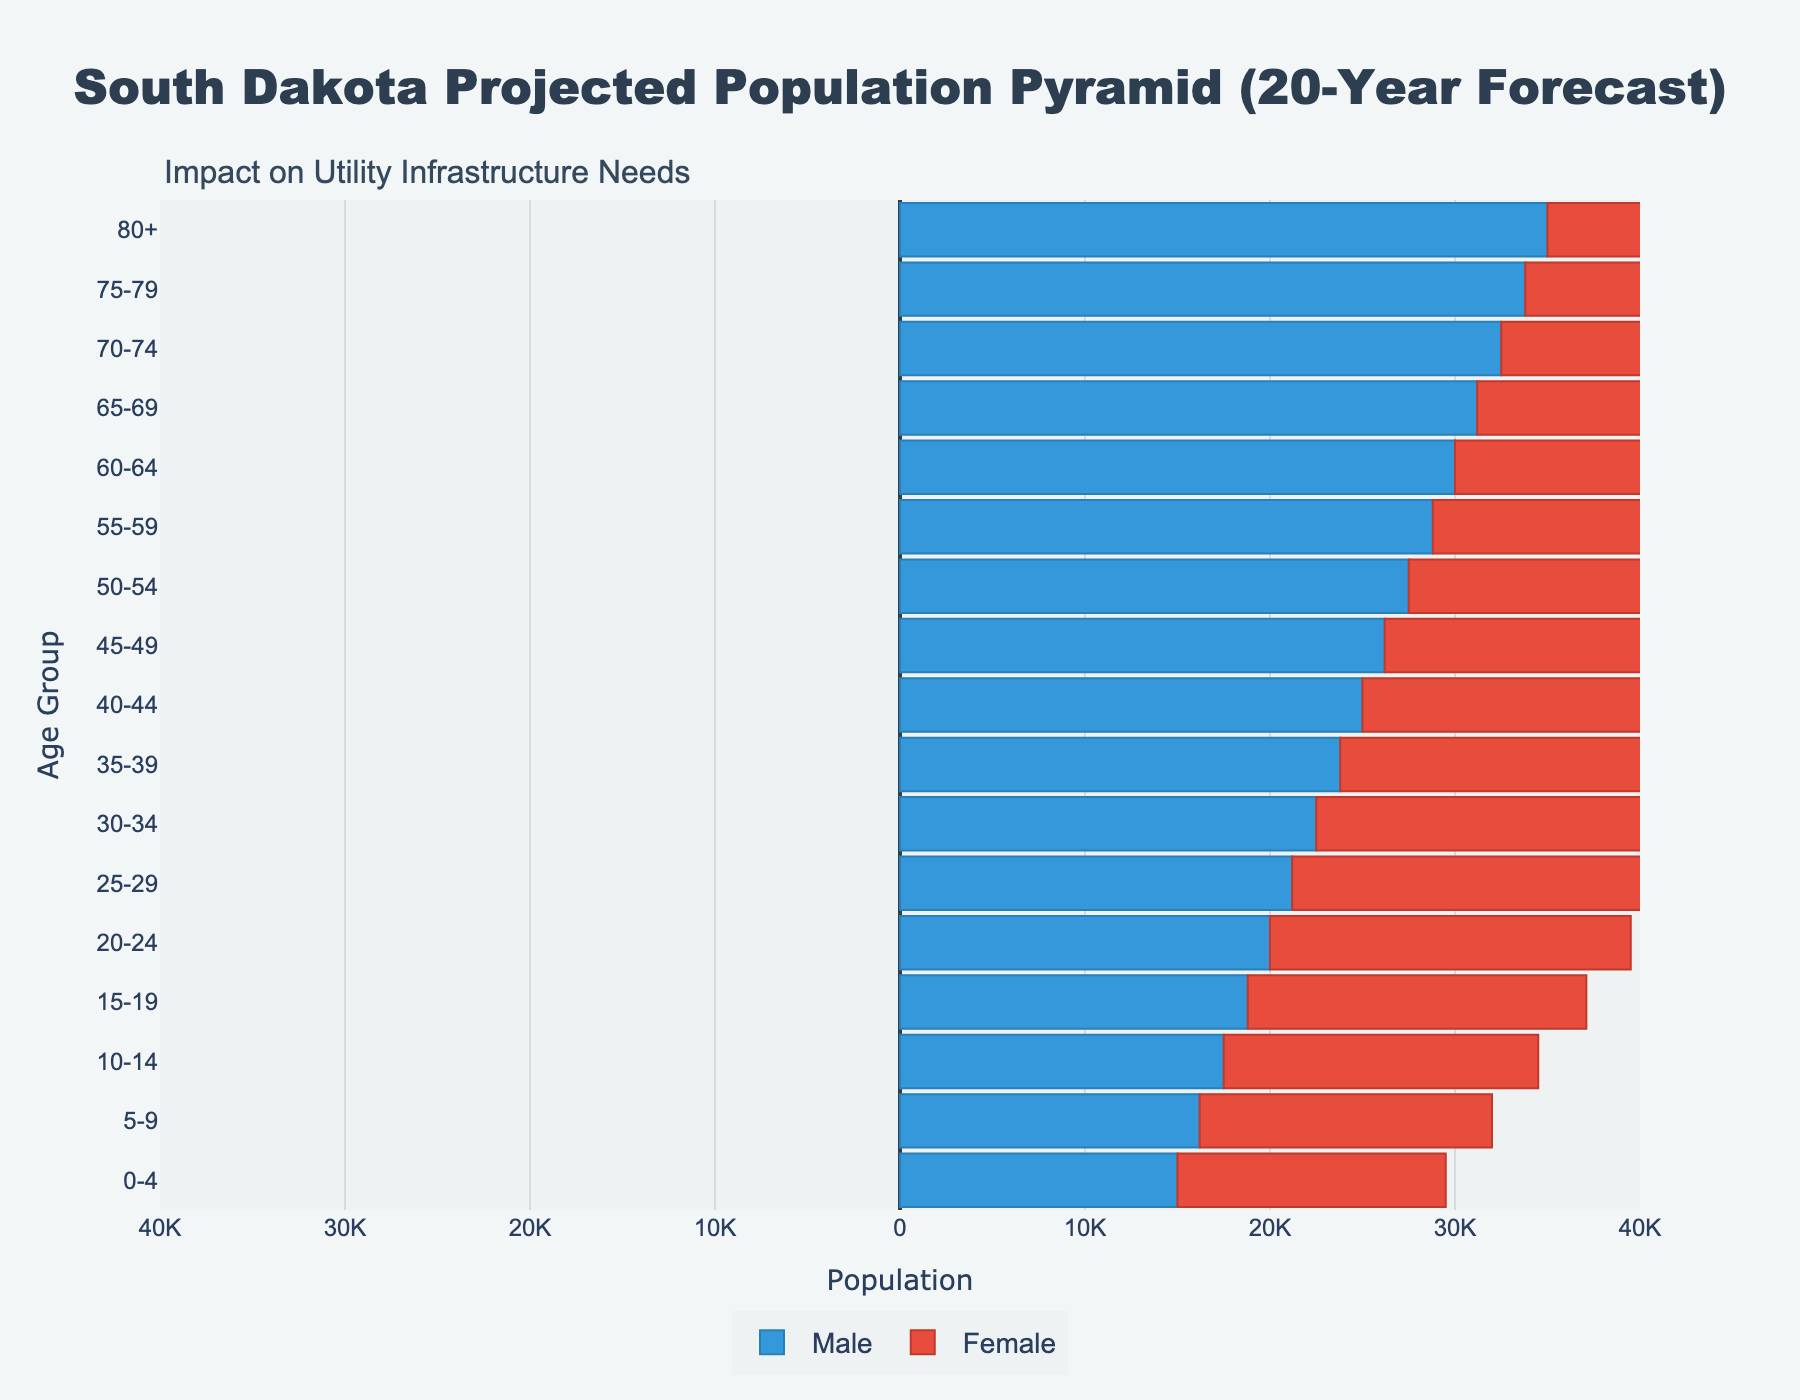What does the title of the figure say? The title is located at the top of the figure and shows the main subject of the plot. The title "South Dakota Projected Population Pyramid (20-Year Forecast)" indicates that it is about the population projection for South Dakota over the next 20 years.
Answer: South Dakota Projected Population Pyramid (20-Year Forecast) What is the largest age group for males? By examining the left side of the pyramid (since male values are negative), we look for the age group with the largest bar. The age group 80+ has a bar reaching the furthest left, indicating it has the largest projected male population.
Answer: 80+ What is the total projected population for the 0-4 age group? Add the values for both males and females in the 0-4 age group. For males, it is -15000 (or 15000 when considering absolute value) and for females, it is 14500. The total is 15000 + 14500.
Answer: 29500 How does the projected population of females in the 5-9 age group compare to males? Check the bars corresponding to the 5-9 age group for both males and females. The female bar is closer to zero than the male bar. Specifically, males have -16200, and females have 15800. 15800 is less than 16200 in absolute value.
Answer: Males have a higher projected population What age group shows a nearly equal projected population between males and females? Look for age groups where the bars for both genders are nearly the same in length. The age group 65-69 is one such group where males have -31200 and females have 30700, which are very close in absolute value.
Answer: 65-69 How many age groups have a male population of more than -25000? Count the age group bars on the left side with values less than -25000. These are 5 in number: 75-79, 70-74, 65-69, 60-64, and 55-59.
Answer: 5 Which gender has a larger population in the 40-44 age group? Compare the lengths of the bars for males and females in the 40-44 age group. Males have -25000, and females have 24500. In absolute terms, 25000 is greater than 24500.
Answer: Males Which age group shows the smallest projected population for females? Identify which bar on the right side is the smallest. The age group 0-4 has the smallest bar with a value of 14500.
Answer: 0-4 What is the sum of the projected population for males in the 30-34 and 35-39 age groups? Sum the absolute values of the male population for these two age groups: 22500 (30-34) and 23800 (35-39). Adding them gives 22500+23800.
Answer: 46300 Which age groups need the most consideration for utility infrastructure planning based on their large populations? Look for age groups with the longest bars on both sides of the pyramid, indicating higher populations. Age groups 75-79, 80+, and 70-74 have the longest bars, suggesting significant future utility infrastructure needs.
Answer: 75-79, 80+, 70-74 